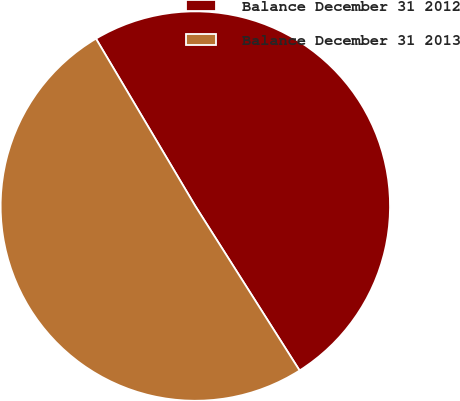Convert chart to OTSL. <chart><loc_0><loc_0><loc_500><loc_500><pie_chart><fcel>Balance December 31 2012<fcel>Balance December 31 2013<nl><fcel>49.53%<fcel>50.47%<nl></chart> 